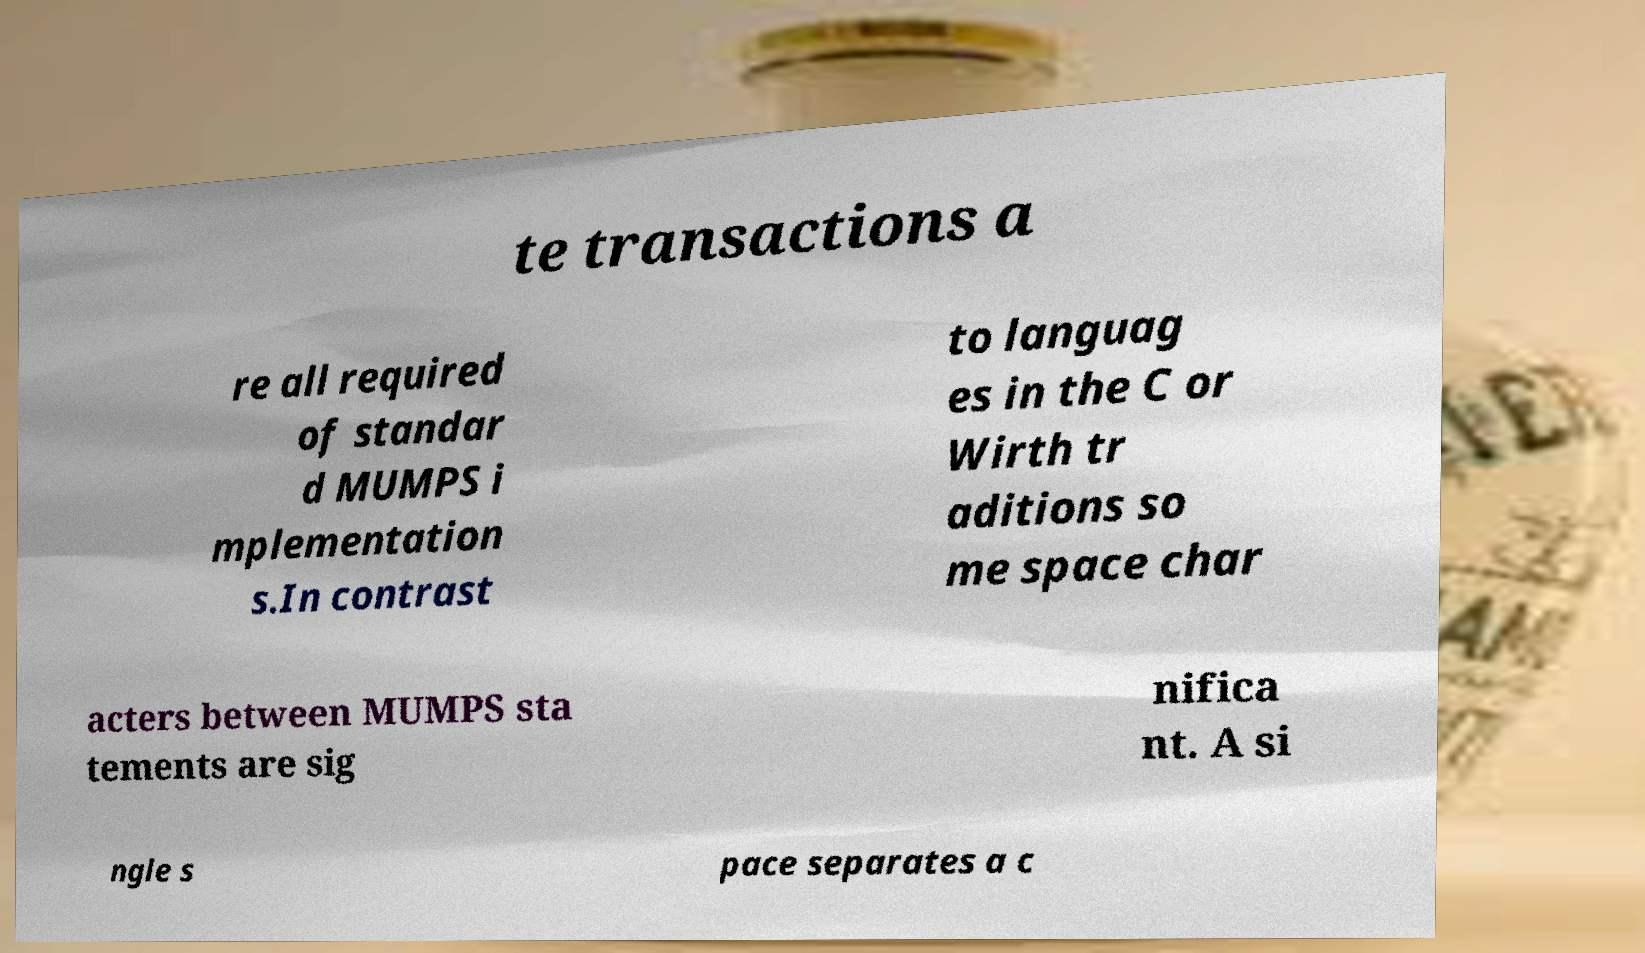Could you extract and type out the text from this image? te transactions a re all required of standar d MUMPS i mplementation s.In contrast to languag es in the C or Wirth tr aditions so me space char acters between MUMPS sta tements are sig nifica nt. A si ngle s pace separates a c 